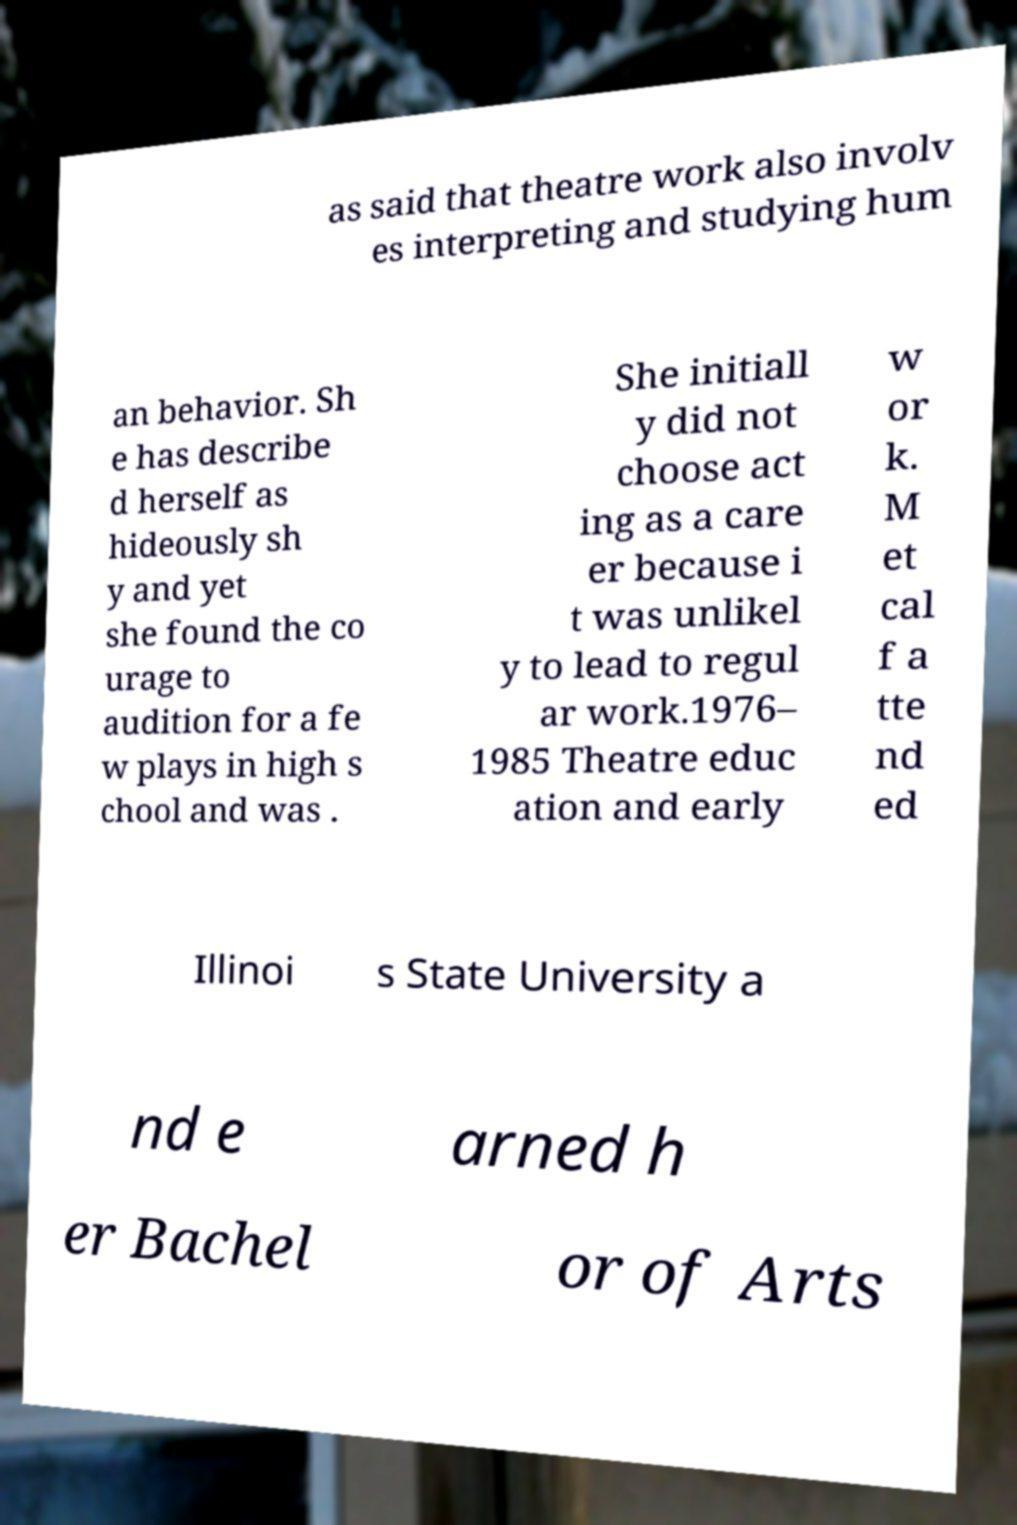Can you accurately transcribe the text from the provided image for me? as said that theatre work also involv es interpreting and studying hum an behavior. Sh e has describe d herself as hideously sh y and yet she found the co urage to audition for a fe w plays in high s chool and was . She initiall y did not choose act ing as a care er because i t was unlikel y to lead to regul ar work.1976– 1985 Theatre educ ation and early w or k. M et cal f a tte nd ed Illinoi s State University a nd e arned h er Bachel or of Arts 